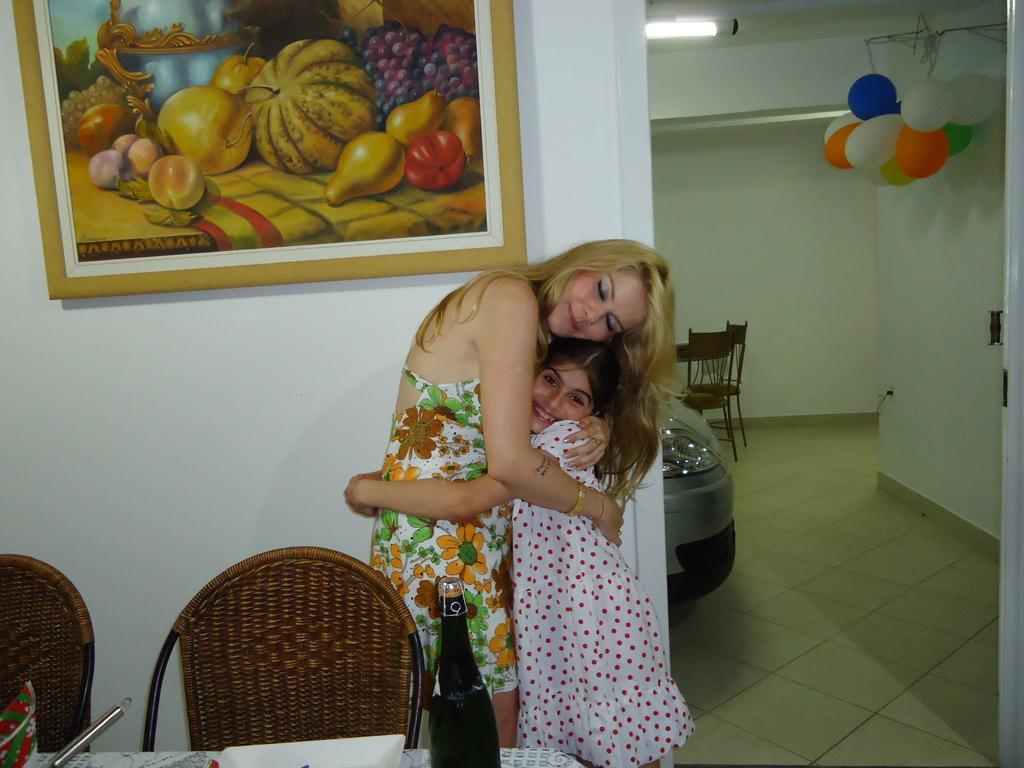How would you summarize this image in a sentence or two? There are two persons. A lady and a girl they are hugging each other. And to the wall there is a frame. And we can see two chairs one water bottle. And to the right there are some balloons. We can see chairs and a car. 